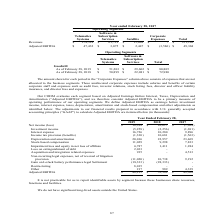According to Calamp's financial document, Why is it not practicable to report identifiable assets by segment? because these businesses share resources, functions and facilities. The document states: "e for us to report identifiable assets by segment because these businesses share resources, functions and facilities...." Also, What was the loss on extinguishment of debt in 2019? According to the financial document, 2,033 (in thousands). The relevant text states: "6,787 1,411 1,284 Loss on extinguishment of debt 2,033 - - Acquisition and integration related expenses 935 - 4,513 Non-recurring legal expenses, net of r..." Also, How much was restructuring in 2019? According to the financial document, 8,015 (in thousands). The relevant text states: "egal Settlement (18,333) (28,333) - Restructuring 8,015 - - Other 217 989 4,339 Adjusted EBITDA $ 48,215 $ 52,382 $ 49,368..." Also, can you calculate: What was the change in interest expense between 2017 and 2018? Based on the calculation: (10,280-9,896), the result is 384 (in thousands). This is based on the information: "e (5,258) (2,256) (1,691) Interest expense 16,726 10,280 9,896 Income tax provision (benefits) (1,330) 10,681 (1,563) Depreciation and amortization 20,016 2 8) (2,256) (1,691) Interest expense 16,726 ..." The key data points involved are: 10,280, 9,896. Also, can you calculate: What was the change in stock-based compensation between 2018 and 2019? Based on the calculation: (11,029-9,298), the result is 1731 (in thousands). This is based on the information: "ion 20,016 22,957 23,469 Stock-based compensation 11,029 9,298 7,833 Impairment loss and equity in net loss of affiliate 6,787 1,411 1,284 Loss on extinguis 016 22,957 23,469 Stock-based compensation ..." The key data points involved are: 11,029, 9,298. Also, can you calculate: What was the percentage change in Depreciation and amortization between 2017 and 2018? To answer this question, I need to perform calculations using the financial data. The calculation is: (22,957-23,469)/23,469, which equals -2.18 (percentage). This is based on the information: ",563) Depreciation and amortization 20,016 22,957 23,469 Stock-based compensation 11,029 9,298 7,833 Impairment loss and equity in net loss of affiliate 6,7 ,681 (1,563) Depreciation and amortization ..." The key data points involved are: 22,957, 23,469. 